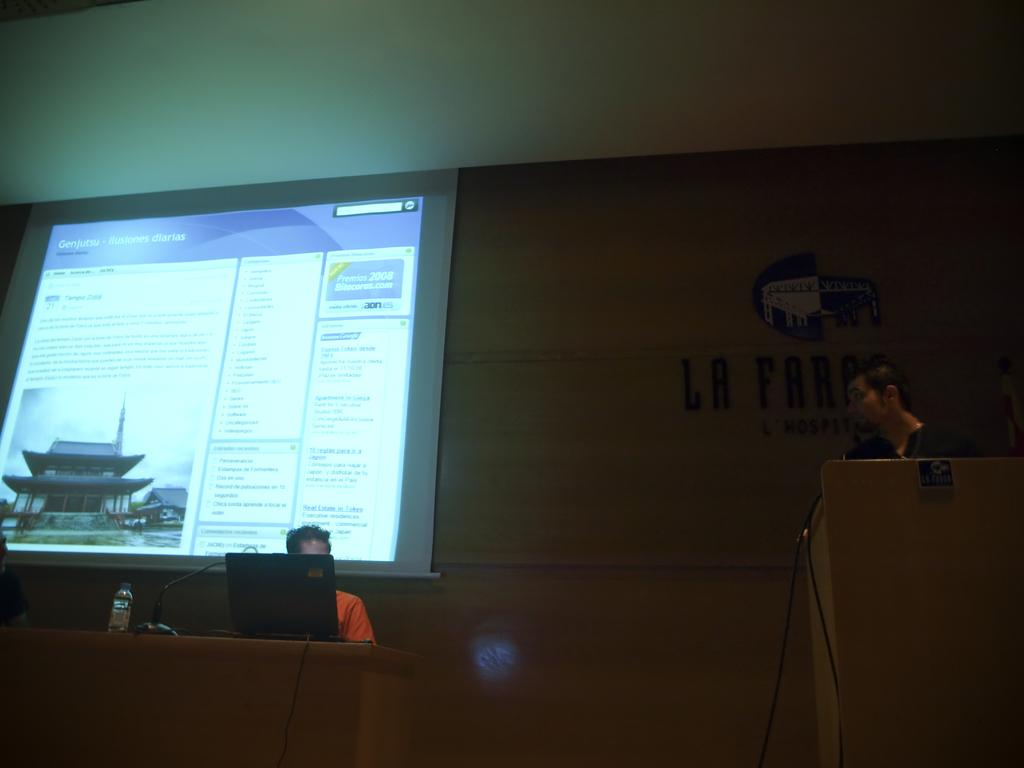How many people are in the image? There are two persons in the image. What is the location of the persons in the image? The persons are in front of a table. What objects are on the table? There is a laptop and a bottle on the table. What can be seen in the background of the image? There is a screen and a wall in the background of the image. Where was the image taken? The image was taken in a hall. What type of iron can be seen on the table in the image? There is no iron present on the table in the image. Is there any snow visible in the image? There is no snow visible in the image; it appears to be taken indoors. 